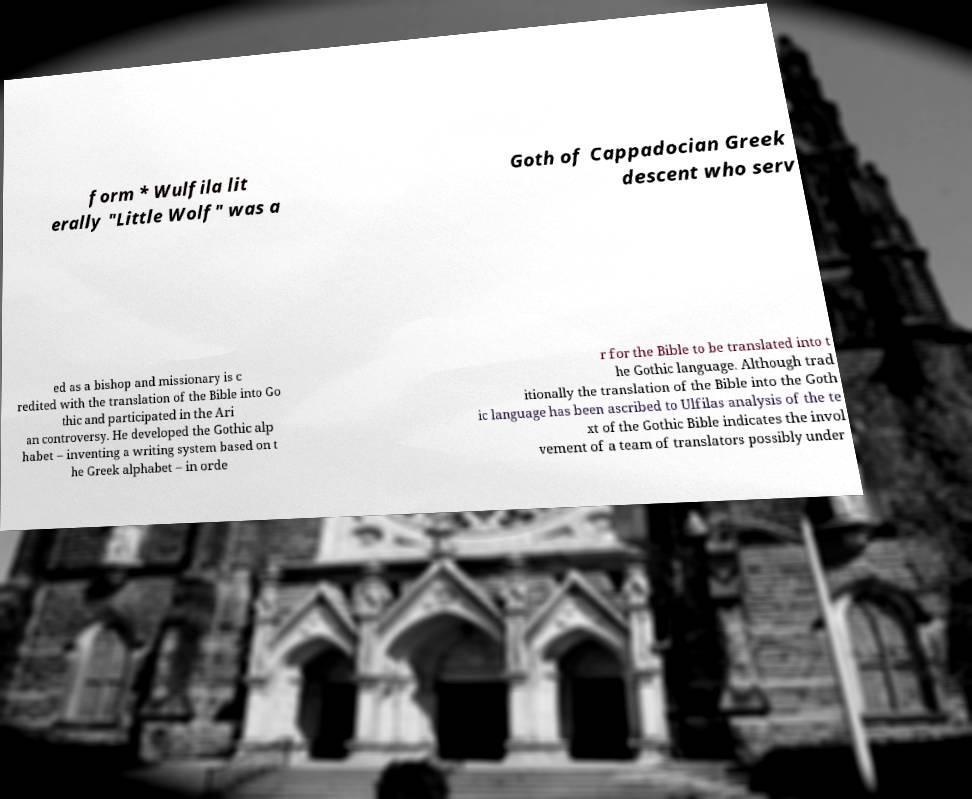Can you accurately transcribe the text from the provided image for me? form * Wulfila lit erally "Little Wolf" was a Goth of Cappadocian Greek descent who serv ed as a bishop and missionary is c redited with the translation of the Bible into Go thic and participated in the Ari an controversy. He developed the Gothic alp habet – inventing a writing system based on t he Greek alphabet – in orde r for the Bible to be translated into t he Gothic language. Although trad itionally the translation of the Bible into the Goth ic language has been ascribed to Ulfilas analysis of the te xt of the Gothic Bible indicates the invol vement of a team of translators possibly under 